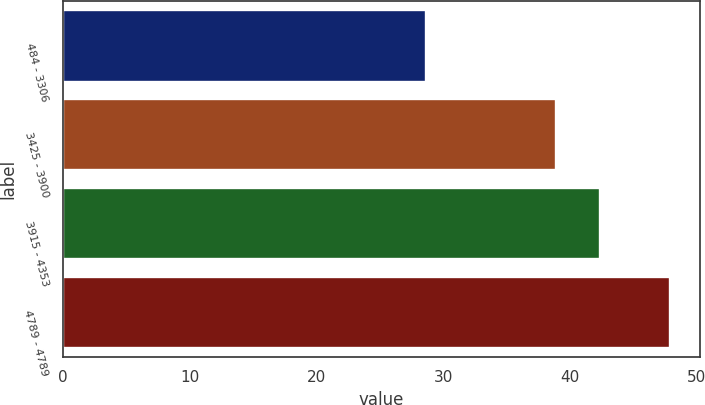Convert chart. <chart><loc_0><loc_0><loc_500><loc_500><bar_chart><fcel>484 - 3306<fcel>3425 - 3900<fcel>3915 - 4353<fcel>4789 - 4789<nl><fcel>28.68<fcel>38.93<fcel>42.39<fcel>47.89<nl></chart> 